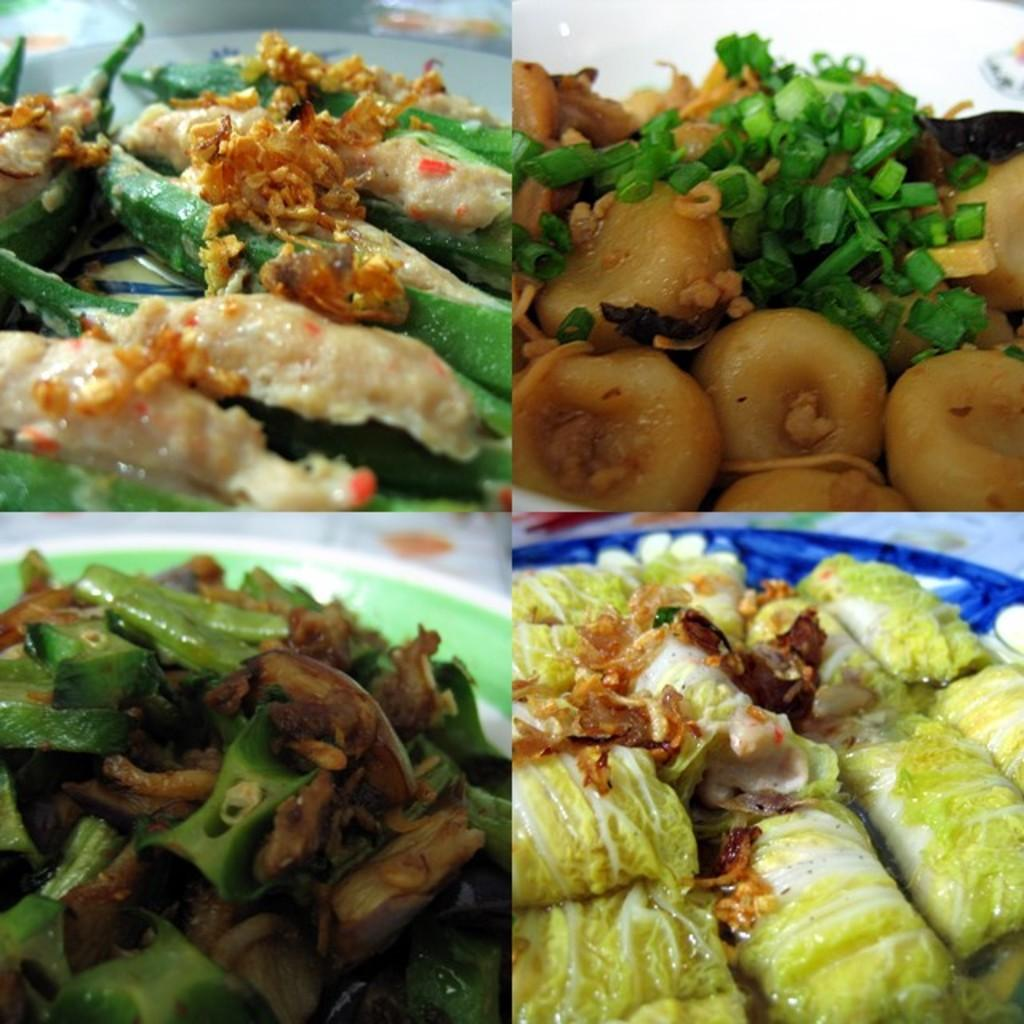What type of artwork is depicted in the image? The image is a collage. What can be seen on the plates in the image? There are food items on plates in the image. How many boys are playing chess in the image? There are no boys or chess games present in the image; it is a collage featuring food items on plates. 